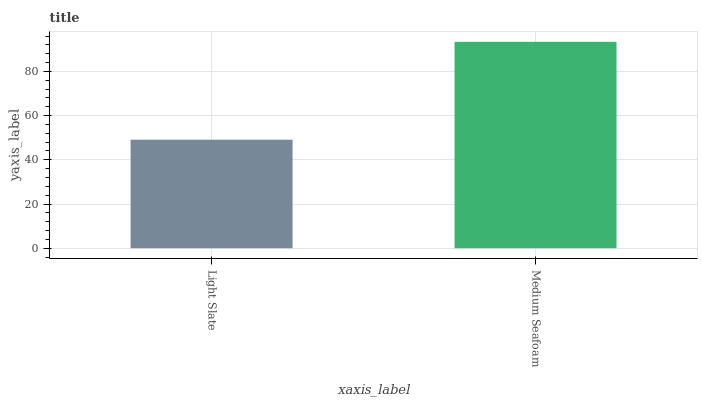Is Medium Seafoam the minimum?
Answer yes or no. No. Is Medium Seafoam greater than Light Slate?
Answer yes or no. Yes. Is Light Slate less than Medium Seafoam?
Answer yes or no. Yes. Is Light Slate greater than Medium Seafoam?
Answer yes or no. No. Is Medium Seafoam less than Light Slate?
Answer yes or no. No. Is Medium Seafoam the high median?
Answer yes or no. Yes. Is Light Slate the low median?
Answer yes or no. Yes. Is Light Slate the high median?
Answer yes or no. No. Is Medium Seafoam the low median?
Answer yes or no. No. 